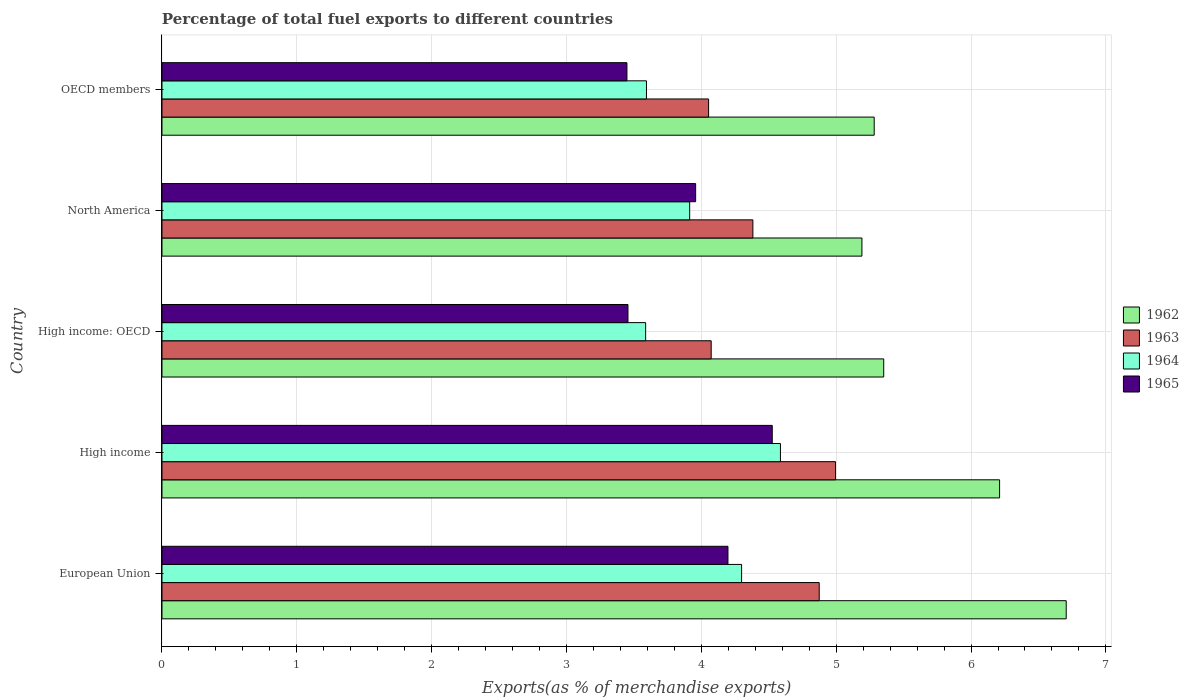How many groups of bars are there?
Provide a succinct answer. 5. Are the number of bars per tick equal to the number of legend labels?
Your answer should be compact. Yes. How many bars are there on the 1st tick from the bottom?
Give a very brief answer. 4. What is the label of the 4th group of bars from the top?
Offer a very short reply. High income. What is the percentage of exports to different countries in 1963 in European Union?
Offer a terse response. 4.87. Across all countries, what is the maximum percentage of exports to different countries in 1964?
Offer a very short reply. 4.59. Across all countries, what is the minimum percentage of exports to different countries in 1965?
Provide a short and direct response. 3.45. In which country was the percentage of exports to different countries in 1963 maximum?
Provide a succinct answer. High income. In which country was the percentage of exports to different countries in 1964 minimum?
Your answer should be very brief. High income: OECD. What is the total percentage of exports to different countries in 1962 in the graph?
Ensure brevity in your answer.  28.74. What is the difference between the percentage of exports to different countries in 1962 in European Union and that in North America?
Give a very brief answer. 1.52. What is the difference between the percentage of exports to different countries in 1965 in OECD members and the percentage of exports to different countries in 1964 in High income?
Keep it short and to the point. -1.14. What is the average percentage of exports to different countries in 1964 per country?
Offer a terse response. 4. What is the difference between the percentage of exports to different countries in 1963 and percentage of exports to different countries in 1965 in OECD members?
Make the answer very short. 0.61. In how many countries, is the percentage of exports to different countries in 1962 greater than 6.6 %?
Provide a short and direct response. 1. What is the ratio of the percentage of exports to different countries in 1964 in High income to that in OECD members?
Give a very brief answer. 1.28. Is the percentage of exports to different countries in 1964 in European Union less than that in OECD members?
Provide a succinct answer. No. What is the difference between the highest and the second highest percentage of exports to different countries in 1963?
Make the answer very short. 0.12. What is the difference between the highest and the lowest percentage of exports to different countries in 1965?
Offer a terse response. 1.08. Is the sum of the percentage of exports to different countries in 1965 in European Union and High income greater than the maximum percentage of exports to different countries in 1962 across all countries?
Provide a short and direct response. Yes. What does the 2nd bar from the top in OECD members represents?
Give a very brief answer. 1964. What does the 4th bar from the bottom in High income: OECD represents?
Provide a succinct answer. 1965. Is it the case that in every country, the sum of the percentage of exports to different countries in 1964 and percentage of exports to different countries in 1962 is greater than the percentage of exports to different countries in 1963?
Offer a terse response. Yes. Does the graph contain grids?
Ensure brevity in your answer.  Yes. What is the title of the graph?
Give a very brief answer. Percentage of total fuel exports to different countries. What is the label or title of the X-axis?
Offer a very short reply. Exports(as % of merchandise exports). What is the label or title of the Y-axis?
Keep it short and to the point. Country. What is the Exports(as % of merchandise exports) of 1962 in European Union?
Your response must be concise. 6.71. What is the Exports(as % of merchandise exports) in 1963 in European Union?
Give a very brief answer. 4.87. What is the Exports(as % of merchandise exports) in 1964 in European Union?
Offer a very short reply. 4.3. What is the Exports(as % of merchandise exports) in 1965 in European Union?
Provide a succinct answer. 4.2. What is the Exports(as % of merchandise exports) in 1962 in High income?
Your response must be concise. 6.21. What is the Exports(as % of merchandise exports) in 1963 in High income?
Offer a very short reply. 5. What is the Exports(as % of merchandise exports) of 1964 in High income?
Ensure brevity in your answer.  4.59. What is the Exports(as % of merchandise exports) in 1965 in High income?
Keep it short and to the point. 4.53. What is the Exports(as % of merchandise exports) of 1962 in High income: OECD?
Provide a short and direct response. 5.35. What is the Exports(as % of merchandise exports) of 1963 in High income: OECD?
Keep it short and to the point. 4.07. What is the Exports(as % of merchandise exports) in 1964 in High income: OECD?
Make the answer very short. 3.59. What is the Exports(as % of merchandise exports) of 1965 in High income: OECD?
Make the answer very short. 3.46. What is the Exports(as % of merchandise exports) in 1962 in North America?
Offer a terse response. 5.19. What is the Exports(as % of merchandise exports) in 1963 in North America?
Offer a terse response. 4.38. What is the Exports(as % of merchandise exports) of 1964 in North America?
Your answer should be compact. 3.91. What is the Exports(as % of merchandise exports) in 1965 in North America?
Ensure brevity in your answer.  3.96. What is the Exports(as % of merchandise exports) in 1962 in OECD members?
Give a very brief answer. 5.28. What is the Exports(as % of merchandise exports) in 1963 in OECD members?
Offer a very short reply. 4.05. What is the Exports(as % of merchandise exports) of 1964 in OECD members?
Give a very brief answer. 3.59. What is the Exports(as % of merchandise exports) in 1965 in OECD members?
Provide a short and direct response. 3.45. Across all countries, what is the maximum Exports(as % of merchandise exports) of 1962?
Your answer should be very brief. 6.71. Across all countries, what is the maximum Exports(as % of merchandise exports) in 1963?
Make the answer very short. 5. Across all countries, what is the maximum Exports(as % of merchandise exports) in 1964?
Your answer should be compact. 4.59. Across all countries, what is the maximum Exports(as % of merchandise exports) in 1965?
Give a very brief answer. 4.53. Across all countries, what is the minimum Exports(as % of merchandise exports) in 1962?
Keep it short and to the point. 5.19. Across all countries, what is the minimum Exports(as % of merchandise exports) in 1963?
Keep it short and to the point. 4.05. Across all countries, what is the minimum Exports(as % of merchandise exports) of 1964?
Provide a succinct answer. 3.59. Across all countries, what is the minimum Exports(as % of merchandise exports) in 1965?
Your answer should be very brief. 3.45. What is the total Exports(as % of merchandise exports) of 1962 in the graph?
Make the answer very short. 28.74. What is the total Exports(as % of merchandise exports) in 1963 in the graph?
Provide a short and direct response. 22.38. What is the total Exports(as % of merchandise exports) of 1964 in the graph?
Ensure brevity in your answer.  19.98. What is the total Exports(as % of merchandise exports) of 1965 in the graph?
Your response must be concise. 19.58. What is the difference between the Exports(as % of merchandise exports) of 1962 in European Union and that in High income?
Offer a very short reply. 0.49. What is the difference between the Exports(as % of merchandise exports) in 1963 in European Union and that in High income?
Offer a very short reply. -0.12. What is the difference between the Exports(as % of merchandise exports) in 1964 in European Union and that in High income?
Keep it short and to the point. -0.29. What is the difference between the Exports(as % of merchandise exports) in 1965 in European Union and that in High income?
Give a very brief answer. -0.33. What is the difference between the Exports(as % of merchandise exports) of 1962 in European Union and that in High income: OECD?
Give a very brief answer. 1.35. What is the difference between the Exports(as % of merchandise exports) of 1963 in European Union and that in High income: OECD?
Your response must be concise. 0.8. What is the difference between the Exports(as % of merchandise exports) of 1964 in European Union and that in High income: OECD?
Your answer should be very brief. 0.71. What is the difference between the Exports(as % of merchandise exports) in 1965 in European Union and that in High income: OECD?
Your answer should be very brief. 0.74. What is the difference between the Exports(as % of merchandise exports) in 1962 in European Union and that in North America?
Offer a terse response. 1.52. What is the difference between the Exports(as % of merchandise exports) of 1963 in European Union and that in North America?
Offer a terse response. 0.49. What is the difference between the Exports(as % of merchandise exports) in 1964 in European Union and that in North America?
Offer a terse response. 0.39. What is the difference between the Exports(as % of merchandise exports) of 1965 in European Union and that in North America?
Give a very brief answer. 0.24. What is the difference between the Exports(as % of merchandise exports) in 1962 in European Union and that in OECD members?
Keep it short and to the point. 1.42. What is the difference between the Exports(as % of merchandise exports) in 1963 in European Union and that in OECD members?
Provide a succinct answer. 0.82. What is the difference between the Exports(as % of merchandise exports) of 1964 in European Union and that in OECD members?
Keep it short and to the point. 0.71. What is the difference between the Exports(as % of merchandise exports) in 1965 in European Union and that in OECD members?
Give a very brief answer. 0.75. What is the difference between the Exports(as % of merchandise exports) in 1962 in High income and that in High income: OECD?
Your answer should be very brief. 0.86. What is the difference between the Exports(as % of merchandise exports) of 1963 in High income and that in High income: OECD?
Provide a succinct answer. 0.92. What is the difference between the Exports(as % of merchandise exports) in 1965 in High income and that in High income: OECD?
Give a very brief answer. 1.07. What is the difference between the Exports(as % of merchandise exports) of 1962 in High income and that in North America?
Keep it short and to the point. 1.02. What is the difference between the Exports(as % of merchandise exports) of 1963 in High income and that in North America?
Provide a succinct answer. 0.61. What is the difference between the Exports(as % of merchandise exports) in 1964 in High income and that in North America?
Keep it short and to the point. 0.67. What is the difference between the Exports(as % of merchandise exports) of 1965 in High income and that in North America?
Give a very brief answer. 0.57. What is the difference between the Exports(as % of merchandise exports) in 1962 in High income and that in OECD members?
Your response must be concise. 0.93. What is the difference between the Exports(as % of merchandise exports) in 1963 in High income and that in OECD members?
Your answer should be compact. 0.94. What is the difference between the Exports(as % of merchandise exports) of 1964 in High income and that in OECD members?
Offer a terse response. 0.99. What is the difference between the Exports(as % of merchandise exports) of 1965 in High income and that in OECD members?
Keep it short and to the point. 1.08. What is the difference between the Exports(as % of merchandise exports) of 1962 in High income: OECD and that in North America?
Make the answer very short. 0.16. What is the difference between the Exports(as % of merchandise exports) in 1963 in High income: OECD and that in North America?
Offer a terse response. -0.31. What is the difference between the Exports(as % of merchandise exports) in 1964 in High income: OECD and that in North America?
Your response must be concise. -0.33. What is the difference between the Exports(as % of merchandise exports) in 1965 in High income: OECD and that in North America?
Give a very brief answer. -0.5. What is the difference between the Exports(as % of merchandise exports) in 1962 in High income: OECD and that in OECD members?
Your response must be concise. 0.07. What is the difference between the Exports(as % of merchandise exports) of 1963 in High income: OECD and that in OECD members?
Ensure brevity in your answer.  0.02. What is the difference between the Exports(as % of merchandise exports) of 1964 in High income: OECD and that in OECD members?
Make the answer very short. -0.01. What is the difference between the Exports(as % of merchandise exports) of 1965 in High income: OECD and that in OECD members?
Provide a succinct answer. 0.01. What is the difference between the Exports(as % of merchandise exports) in 1962 in North America and that in OECD members?
Your answer should be very brief. -0.09. What is the difference between the Exports(as % of merchandise exports) of 1963 in North America and that in OECD members?
Provide a succinct answer. 0.33. What is the difference between the Exports(as % of merchandise exports) of 1964 in North America and that in OECD members?
Make the answer very short. 0.32. What is the difference between the Exports(as % of merchandise exports) of 1965 in North America and that in OECD members?
Ensure brevity in your answer.  0.51. What is the difference between the Exports(as % of merchandise exports) in 1962 in European Union and the Exports(as % of merchandise exports) in 1963 in High income?
Ensure brevity in your answer.  1.71. What is the difference between the Exports(as % of merchandise exports) in 1962 in European Union and the Exports(as % of merchandise exports) in 1964 in High income?
Your answer should be compact. 2.12. What is the difference between the Exports(as % of merchandise exports) of 1962 in European Union and the Exports(as % of merchandise exports) of 1965 in High income?
Offer a very short reply. 2.18. What is the difference between the Exports(as % of merchandise exports) in 1963 in European Union and the Exports(as % of merchandise exports) in 1964 in High income?
Give a very brief answer. 0.29. What is the difference between the Exports(as % of merchandise exports) in 1963 in European Union and the Exports(as % of merchandise exports) in 1965 in High income?
Ensure brevity in your answer.  0.35. What is the difference between the Exports(as % of merchandise exports) in 1964 in European Union and the Exports(as % of merchandise exports) in 1965 in High income?
Your answer should be very brief. -0.23. What is the difference between the Exports(as % of merchandise exports) in 1962 in European Union and the Exports(as % of merchandise exports) in 1963 in High income: OECD?
Keep it short and to the point. 2.63. What is the difference between the Exports(as % of merchandise exports) in 1962 in European Union and the Exports(as % of merchandise exports) in 1964 in High income: OECD?
Offer a terse response. 3.12. What is the difference between the Exports(as % of merchandise exports) of 1962 in European Union and the Exports(as % of merchandise exports) of 1965 in High income: OECD?
Your response must be concise. 3.25. What is the difference between the Exports(as % of merchandise exports) of 1963 in European Union and the Exports(as % of merchandise exports) of 1964 in High income: OECD?
Ensure brevity in your answer.  1.29. What is the difference between the Exports(as % of merchandise exports) of 1963 in European Union and the Exports(as % of merchandise exports) of 1965 in High income: OECD?
Your answer should be compact. 1.42. What is the difference between the Exports(as % of merchandise exports) of 1964 in European Union and the Exports(as % of merchandise exports) of 1965 in High income: OECD?
Offer a very short reply. 0.84. What is the difference between the Exports(as % of merchandise exports) in 1962 in European Union and the Exports(as % of merchandise exports) in 1963 in North America?
Make the answer very short. 2.32. What is the difference between the Exports(as % of merchandise exports) in 1962 in European Union and the Exports(as % of merchandise exports) in 1964 in North America?
Provide a succinct answer. 2.79. What is the difference between the Exports(as % of merchandise exports) of 1962 in European Union and the Exports(as % of merchandise exports) of 1965 in North America?
Provide a short and direct response. 2.75. What is the difference between the Exports(as % of merchandise exports) of 1963 in European Union and the Exports(as % of merchandise exports) of 1964 in North America?
Provide a succinct answer. 0.96. What is the difference between the Exports(as % of merchandise exports) in 1963 in European Union and the Exports(as % of merchandise exports) in 1965 in North America?
Give a very brief answer. 0.92. What is the difference between the Exports(as % of merchandise exports) in 1964 in European Union and the Exports(as % of merchandise exports) in 1965 in North America?
Give a very brief answer. 0.34. What is the difference between the Exports(as % of merchandise exports) of 1962 in European Union and the Exports(as % of merchandise exports) of 1963 in OECD members?
Your answer should be compact. 2.65. What is the difference between the Exports(as % of merchandise exports) of 1962 in European Union and the Exports(as % of merchandise exports) of 1964 in OECD members?
Offer a terse response. 3.11. What is the difference between the Exports(as % of merchandise exports) of 1962 in European Union and the Exports(as % of merchandise exports) of 1965 in OECD members?
Your response must be concise. 3.26. What is the difference between the Exports(as % of merchandise exports) in 1963 in European Union and the Exports(as % of merchandise exports) in 1964 in OECD members?
Your response must be concise. 1.28. What is the difference between the Exports(as % of merchandise exports) of 1963 in European Union and the Exports(as % of merchandise exports) of 1965 in OECD members?
Keep it short and to the point. 1.43. What is the difference between the Exports(as % of merchandise exports) in 1964 in European Union and the Exports(as % of merchandise exports) in 1965 in OECD members?
Your answer should be very brief. 0.85. What is the difference between the Exports(as % of merchandise exports) of 1962 in High income and the Exports(as % of merchandise exports) of 1963 in High income: OECD?
Keep it short and to the point. 2.14. What is the difference between the Exports(as % of merchandise exports) of 1962 in High income and the Exports(as % of merchandise exports) of 1964 in High income: OECD?
Your answer should be compact. 2.62. What is the difference between the Exports(as % of merchandise exports) in 1962 in High income and the Exports(as % of merchandise exports) in 1965 in High income: OECD?
Give a very brief answer. 2.76. What is the difference between the Exports(as % of merchandise exports) in 1963 in High income and the Exports(as % of merchandise exports) in 1964 in High income: OECD?
Offer a terse response. 1.41. What is the difference between the Exports(as % of merchandise exports) of 1963 in High income and the Exports(as % of merchandise exports) of 1965 in High income: OECD?
Ensure brevity in your answer.  1.54. What is the difference between the Exports(as % of merchandise exports) in 1964 in High income and the Exports(as % of merchandise exports) in 1965 in High income: OECD?
Offer a very short reply. 1.13. What is the difference between the Exports(as % of merchandise exports) in 1962 in High income and the Exports(as % of merchandise exports) in 1963 in North America?
Make the answer very short. 1.83. What is the difference between the Exports(as % of merchandise exports) of 1962 in High income and the Exports(as % of merchandise exports) of 1964 in North America?
Make the answer very short. 2.3. What is the difference between the Exports(as % of merchandise exports) in 1962 in High income and the Exports(as % of merchandise exports) in 1965 in North America?
Offer a terse response. 2.25. What is the difference between the Exports(as % of merchandise exports) of 1963 in High income and the Exports(as % of merchandise exports) of 1964 in North America?
Ensure brevity in your answer.  1.08. What is the difference between the Exports(as % of merchandise exports) in 1963 in High income and the Exports(as % of merchandise exports) in 1965 in North America?
Provide a succinct answer. 1.04. What is the difference between the Exports(as % of merchandise exports) in 1964 in High income and the Exports(as % of merchandise exports) in 1965 in North America?
Your answer should be compact. 0.63. What is the difference between the Exports(as % of merchandise exports) in 1962 in High income and the Exports(as % of merchandise exports) in 1963 in OECD members?
Your answer should be very brief. 2.16. What is the difference between the Exports(as % of merchandise exports) in 1962 in High income and the Exports(as % of merchandise exports) in 1964 in OECD members?
Provide a succinct answer. 2.62. What is the difference between the Exports(as % of merchandise exports) of 1962 in High income and the Exports(as % of merchandise exports) of 1965 in OECD members?
Give a very brief answer. 2.76. What is the difference between the Exports(as % of merchandise exports) in 1963 in High income and the Exports(as % of merchandise exports) in 1964 in OECD members?
Your answer should be very brief. 1.4. What is the difference between the Exports(as % of merchandise exports) in 1963 in High income and the Exports(as % of merchandise exports) in 1965 in OECD members?
Your answer should be compact. 1.55. What is the difference between the Exports(as % of merchandise exports) in 1964 in High income and the Exports(as % of merchandise exports) in 1965 in OECD members?
Offer a very short reply. 1.14. What is the difference between the Exports(as % of merchandise exports) in 1962 in High income: OECD and the Exports(as % of merchandise exports) in 1963 in North America?
Your answer should be compact. 0.97. What is the difference between the Exports(as % of merchandise exports) in 1962 in High income: OECD and the Exports(as % of merchandise exports) in 1964 in North America?
Make the answer very short. 1.44. What is the difference between the Exports(as % of merchandise exports) in 1962 in High income: OECD and the Exports(as % of merchandise exports) in 1965 in North America?
Your response must be concise. 1.39. What is the difference between the Exports(as % of merchandise exports) of 1963 in High income: OECD and the Exports(as % of merchandise exports) of 1964 in North America?
Ensure brevity in your answer.  0.16. What is the difference between the Exports(as % of merchandise exports) in 1963 in High income: OECD and the Exports(as % of merchandise exports) in 1965 in North America?
Give a very brief answer. 0.12. What is the difference between the Exports(as % of merchandise exports) in 1964 in High income: OECD and the Exports(as % of merchandise exports) in 1965 in North America?
Offer a terse response. -0.37. What is the difference between the Exports(as % of merchandise exports) of 1962 in High income: OECD and the Exports(as % of merchandise exports) of 1963 in OECD members?
Make the answer very short. 1.3. What is the difference between the Exports(as % of merchandise exports) in 1962 in High income: OECD and the Exports(as % of merchandise exports) in 1964 in OECD members?
Your response must be concise. 1.76. What is the difference between the Exports(as % of merchandise exports) of 1962 in High income: OECD and the Exports(as % of merchandise exports) of 1965 in OECD members?
Ensure brevity in your answer.  1.9. What is the difference between the Exports(as % of merchandise exports) in 1963 in High income: OECD and the Exports(as % of merchandise exports) in 1964 in OECD members?
Offer a very short reply. 0.48. What is the difference between the Exports(as % of merchandise exports) in 1963 in High income: OECD and the Exports(as % of merchandise exports) in 1965 in OECD members?
Keep it short and to the point. 0.62. What is the difference between the Exports(as % of merchandise exports) of 1964 in High income: OECD and the Exports(as % of merchandise exports) of 1965 in OECD members?
Provide a succinct answer. 0.14. What is the difference between the Exports(as % of merchandise exports) in 1962 in North America and the Exports(as % of merchandise exports) in 1963 in OECD members?
Give a very brief answer. 1.14. What is the difference between the Exports(as % of merchandise exports) in 1962 in North America and the Exports(as % of merchandise exports) in 1964 in OECD members?
Provide a succinct answer. 1.6. What is the difference between the Exports(as % of merchandise exports) of 1962 in North America and the Exports(as % of merchandise exports) of 1965 in OECD members?
Give a very brief answer. 1.74. What is the difference between the Exports(as % of merchandise exports) in 1963 in North America and the Exports(as % of merchandise exports) in 1964 in OECD members?
Give a very brief answer. 0.79. What is the difference between the Exports(as % of merchandise exports) in 1963 in North America and the Exports(as % of merchandise exports) in 1965 in OECD members?
Ensure brevity in your answer.  0.93. What is the difference between the Exports(as % of merchandise exports) in 1964 in North America and the Exports(as % of merchandise exports) in 1965 in OECD members?
Your answer should be very brief. 0.47. What is the average Exports(as % of merchandise exports) in 1962 per country?
Your response must be concise. 5.75. What is the average Exports(as % of merchandise exports) in 1963 per country?
Provide a succinct answer. 4.48. What is the average Exports(as % of merchandise exports) of 1964 per country?
Ensure brevity in your answer.  4. What is the average Exports(as % of merchandise exports) of 1965 per country?
Give a very brief answer. 3.92. What is the difference between the Exports(as % of merchandise exports) in 1962 and Exports(as % of merchandise exports) in 1963 in European Union?
Give a very brief answer. 1.83. What is the difference between the Exports(as % of merchandise exports) of 1962 and Exports(as % of merchandise exports) of 1964 in European Union?
Your answer should be very brief. 2.41. What is the difference between the Exports(as % of merchandise exports) in 1962 and Exports(as % of merchandise exports) in 1965 in European Union?
Your response must be concise. 2.51. What is the difference between the Exports(as % of merchandise exports) in 1963 and Exports(as % of merchandise exports) in 1964 in European Union?
Your answer should be very brief. 0.58. What is the difference between the Exports(as % of merchandise exports) of 1963 and Exports(as % of merchandise exports) of 1965 in European Union?
Keep it short and to the point. 0.68. What is the difference between the Exports(as % of merchandise exports) of 1964 and Exports(as % of merchandise exports) of 1965 in European Union?
Your response must be concise. 0.1. What is the difference between the Exports(as % of merchandise exports) in 1962 and Exports(as % of merchandise exports) in 1963 in High income?
Your answer should be very brief. 1.22. What is the difference between the Exports(as % of merchandise exports) in 1962 and Exports(as % of merchandise exports) in 1964 in High income?
Your answer should be very brief. 1.63. What is the difference between the Exports(as % of merchandise exports) of 1962 and Exports(as % of merchandise exports) of 1965 in High income?
Offer a terse response. 1.69. What is the difference between the Exports(as % of merchandise exports) in 1963 and Exports(as % of merchandise exports) in 1964 in High income?
Provide a succinct answer. 0.41. What is the difference between the Exports(as % of merchandise exports) of 1963 and Exports(as % of merchandise exports) of 1965 in High income?
Your response must be concise. 0.47. What is the difference between the Exports(as % of merchandise exports) in 1964 and Exports(as % of merchandise exports) in 1965 in High income?
Your response must be concise. 0.06. What is the difference between the Exports(as % of merchandise exports) of 1962 and Exports(as % of merchandise exports) of 1963 in High income: OECD?
Offer a very short reply. 1.28. What is the difference between the Exports(as % of merchandise exports) in 1962 and Exports(as % of merchandise exports) in 1964 in High income: OECD?
Offer a terse response. 1.77. What is the difference between the Exports(as % of merchandise exports) of 1962 and Exports(as % of merchandise exports) of 1965 in High income: OECD?
Your response must be concise. 1.9. What is the difference between the Exports(as % of merchandise exports) of 1963 and Exports(as % of merchandise exports) of 1964 in High income: OECD?
Ensure brevity in your answer.  0.49. What is the difference between the Exports(as % of merchandise exports) of 1963 and Exports(as % of merchandise exports) of 1965 in High income: OECD?
Provide a succinct answer. 0.62. What is the difference between the Exports(as % of merchandise exports) of 1964 and Exports(as % of merchandise exports) of 1965 in High income: OECD?
Offer a very short reply. 0.13. What is the difference between the Exports(as % of merchandise exports) of 1962 and Exports(as % of merchandise exports) of 1963 in North America?
Your response must be concise. 0.81. What is the difference between the Exports(as % of merchandise exports) of 1962 and Exports(as % of merchandise exports) of 1964 in North America?
Offer a very short reply. 1.28. What is the difference between the Exports(as % of merchandise exports) of 1962 and Exports(as % of merchandise exports) of 1965 in North America?
Keep it short and to the point. 1.23. What is the difference between the Exports(as % of merchandise exports) of 1963 and Exports(as % of merchandise exports) of 1964 in North America?
Offer a very short reply. 0.47. What is the difference between the Exports(as % of merchandise exports) of 1963 and Exports(as % of merchandise exports) of 1965 in North America?
Ensure brevity in your answer.  0.42. What is the difference between the Exports(as % of merchandise exports) of 1964 and Exports(as % of merchandise exports) of 1965 in North America?
Your answer should be compact. -0.04. What is the difference between the Exports(as % of merchandise exports) in 1962 and Exports(as % of merchandise exports) in 1963 in OECD members?
Provide a short and direct response. 1.23. What is the difference between the Exports(as % of merchandise exports) of 1962 and Exports(as % of merchandise exports) of 1964 in OECD members?
Make the answer very short. 1.69. What is the difference between the Exports(as % of merchandise exports) in 1962 and Exports(as % of merchandise exports) in 1965 in OECD members?
Your response must be concise. 1.83. What is the difference between the Exports(as % of merchandise exports) in 1963 and Exports(as % of merchandise exports) in 1964 in OECD members?
Make the answer very short. 0.46. What is the difference between the Exports(as % of merchandise exports) of 1963 and Exports(as % of merchandise exports) of 1965 in OECD members?
Provide a succinct answer. 0.61. What is the difference between the Exports(as % of merchandise exports) of 1964 and Exports(as % of merchandise exports) of 1965 in OECD members?
Make the answer very short. 0.14. What is the ratio of the Exports(as % of merchandise exports) in 1962 in European Union to that in High income?
Offer a terse response. 1.08. What is the ratio of the Exports(as % of merchandise exports) of 1963 in European Union to that in High income?
Your answer should be very brief. 0.98. What is the ratio of the Exports(as % of merchandise exports) of 1964 in European Union to that in High income?
Offer a very short reply. 0.94. What is the ratio of the Exports(as % of merchandise exports) in 1965 in European Union to that in High income?
Offer a terse response. 0.93. What is the ratio of the Exports(as % of merchandise exports) of 1962 in European Union to that in High income: OECD?
Provide a short and direct response. 1.25. What is the ratio of the Exports(as % of merchandise exports) in 1963 in European Union to that in High income: OECD?
Make the answer very short. 1.2. What is the ratio of the Exports(as % of merchandise exports) in 1964 in European Union to that in High income: OECD?
Provide a succinct answer. 1.2. What is the ratio of the Exports(as % of merchandise exports) of 1965 in European Union to that in High income: OECD?
Your response must be concise. 1.21. What is the ratio of the Exports(as % of merchandise exports) in 1962 in European Union to that in North America?
Give a very brief answer. 1.29. What is the ratio of the Exports(as % of merchandise exports) in 1963 in European Union to that in North America?
Make the answer very short. 1.11. What is the ratio of the Exports(as % of merchandise exports) of 1964 in European Union to that in North America?
Provide a succinct answer. 1.1. What is the ratio of the Exports(as % of merchandise exports) in 1965 in European Union to that in North America?
Provide a succinct answer. 1.06. What is the ratio of the Exports(as % of merchandise exports) in 1962 in European Union to that in OECD members?
Offer a very short reply. 1.27. What is the ratio of the Exports(as % of merchandise exports) of 1963 in European Union to that in OECD members?
Your response must be concise. 1.2. What is the ratio of the Exports(as % of merchandise exports) of 1964 in European Union to that in OECD members?
Ensure brevity in your answer.  1.2. What is the ratio of the Exports(as % of merchandise exports) of 1965 in European Union to that in OECD members?
Make the answer very short. 1.22. What is the ratio of the Exports(as % of merchandise exports) in 1962 in High income to that in High income: OECD?
Provide a succinct answer. 1.16. What is the ratio of the Exports(as % of merchandise exports) in 1963 in High income to that in High income: OECD?
Your answer should be compact. 1.23. What is the ratio of the Exports(as % of merchandise exports) of 1964 in High income to that in High income: OECD?
Offer a very short reply. 1.28. What is the ratio of the Exports(as % of merchandise exports) in 1965 in High income to that in High income: OECD?
Make the answer very short. 1.31. What is the ratio of the Exports(as % of merchandise exports) of 1962 in High income to that in North America?
Give a very brief answer. 1.2. What is the ratio of the Exports(as % of merchandise exports) in 1963 in High income to that in North America?
Provide a succinct answer. 1.14. What is the ratio of the Exports(as % of merchandise exports) in 1964 in High income to that in North America?
Provide a short and direct response. 1.17. What is the ratio of the Exports(as % of merchandise exports) of 1965 in High income to that in North America?
Your answer should be very brief. 1.14. What is the ratio of the Exports(as % of merchandise exports) of 1962 in High income to that in OECD members?
Provide a short and direct response. 1.18. What is the ratio of the Exports(as % of merchandise exports) of 1963 in High income to that in OECD members?
Provide a short and direct response. 1.23. What is the ratio of the Exports(as % of merchandise exports) in 1964 in High income to that in OECD members?
Offer a terse response. 1.28. What is the ratio of the Exports(as % of merchandise exports) of 1965 in High income to that in OECD members?
Ensure brevity in your answer.  1.31. What is the ratio of the Exports(as % of merchandise exports) of 1962 in High income: OECD to that in North America?
Provide a short and direct response. 1.03. What is the ratio of the Exports(as % of merchandise exports) in 1963 in High income: OECD to that in North America?
Offer a very short reply. 0.93. What is the ratio of the Exports(as % of merchandise exports) of 1964 in High income: OECD to that in North America?
Offer a very short reply. 0.92. What is the ratio of the Exports(as % of merchandise exports) in 1965 in High income: OECD to that in North America?
Make the answer very short. 0.87. What is the ratio of the Exports(as % of merchandise exports) in 1962 in High income: OECD to that in OECD members?
Keep it short and to the point. 1.01. What is the ratio of the Exports(as % of merchandise exports) of 1963 in High income: OECD to that in OECD members?
Provide a succinct answer. 1. What is the ratio of the Exports(as % of merchandise exports) in 1964 in High income: OECD to that in OECD members?
Give a very brief answer. 1. What is the ratio of the Exports(as % of merchandise exports) in 1965 in High income: OECD to that in OECD members?
Make the answer very short. 1. What is the ratio of the Exports(as % of merchandise exports) in 1962 in North America to that in OECD members?
Your answer should be very brief. 0.98. What is the ratio of the Exports(as % of merchandise exports) in 1963 in North America to that in OECD members?
Provide a succinct answer. 1.08. What is the ratio of the Exports(as % of merchandise exports) of 1964 in North America to that in OECD members?
Keep it short and to the point. 1.09. What is the ratio of the Exports(as % of merchandise exports) of 1965 in North America to that in OECD members?
Offer a very short reply. 1.15. What is the difference between the highest and the second highest Exports(as % of merchandise exports) of 1962?
Your answer should be very brief. 0.49. What is the difference between the highest and the second highest Exports(as % of merchandise exports) of 1963?
Make the answer very short. 0.12. What is the difference between the highest and the second highest Exports(as % of merchandise exports) of 1964?
Your response must be concise. 0.29. What is the difference between the highest and the second highest Exports(as % of merchandise exports) in 1965?
Your answer should be compact. 0.33. What is the difference between the highest and the lowest Exports(as % of merchandise exports) in 1962?
Your answer should be very brief. 1.52. What is the difference between the highest and the lowest Exports(as % of merchandise exports) in 1963?
Make the answer very short. 0.94. What is the difference between the highest and the lowest Exports(as % of merchandise exports) in 1964?
Offer a very short reply. 1. What is the difference between the highest and the lowest Exports(as % of merchandise exports) in 1965?
Provide a succinct answer. 1.08. 